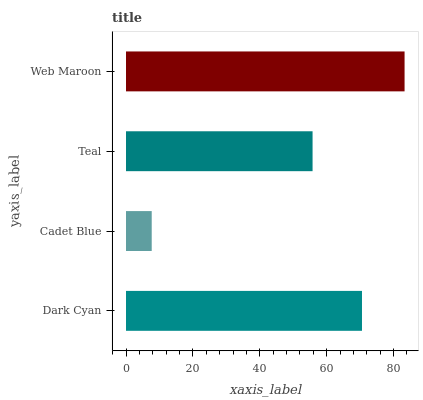Is Cadet Blue the minimum?
Answer yes or no. Yes. Is Web Maroon the maximum?
Answer yes or no. Yes. Is Teal the minimum?
Answer yes or no. No. Is Teal the maximum?
Answer yes or no. No. Is Teal greater than Cadet Blue?
Answer yes or no. Yes. Is Cadet Blue less than Teal?
Answer yes or no. Yes. Is Cadet Blue greater than Teal?
Answer yes or no. No. Is Teal less than Cadet Blue?
Answer yes or no. No. Is Dark Cyan the high median?
Answer yes or no. Yes. Is Teal the low median?
Answer yes or no. Yes. Is Web Maroon the high median?
Answer yes or no. No. Is Dark Cyan the low median?
Answer yes or no. No. 